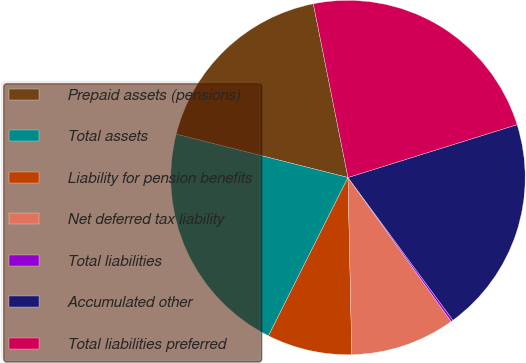Convert chart to OTSL. <chart><loc_0><loc_0><loc_500><loc_500><pie_chart><fcel>Prepaid assets (pensions)<fcel>Total assets<fcel>Liability for pension benefits<fcel>Net deferred tax liability<fcel>Total liabilities<fcel>Accumulated other<fcel>Total liabilities preferred<nl><fcel>17.93%<fcel>21.52%<fcel>7.75%<fcel>9.55%<fcel>0.2%<fcel>19.73%<fcel>23.31%<nl></chart> 